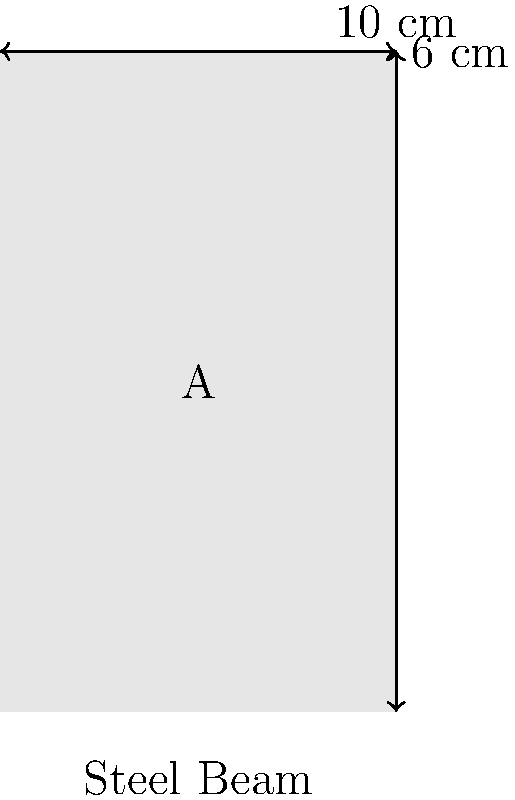A steel beam with a rectangular cross-section is shown above. The beam has a width of 6 cm and a height of 10 cm. If the yield strength of the steel is 250 MPa, calculate the maximum bending moment that the beam can safely support before yielding occurs. Assume the beam is subjected to pure bending and use the elastic section modulus method. To solve this problem, we'll follow these steps:

1) Calculate the moment of inertia (I) of the rectangular cross-section:
   $$I = \frac{bh^3}{12}$$
   where b is the width and h is the height of the cross-section.
   $$I = \frac{6 \cdot 10^3}{12} = 500 \text{ cm}^4$$

2) Calculate the distance from the neutral axis to the extreme fiber (c):
   $$c = \frac{h}{2} = \frac{10}{2} = 5 \text{ cm}$$

3) Calculate the elastic section modulus (S):
   $$S = \frac{I}{c} = \frac{500}{5} = 100 \text{ cm}^3 = 100 \times 10^{-6} \text{ m}^3$$

4) Use the flexure formula to calculate the maximum bending moment (M):
   $$M = \frac{\sigma_y \cdot I}{c} = \sigma_y \cdot S$$
   where $\sigma_y$ is the yield strength of the steel.

   $$M = 250 \times 10^6 \text{ Pa} \cdot 100 \times 10^{-6} \text{ m}^3 = 25,000 \text{ N·m}$$

Therefore, the maximum bending moment the beam can safely support is 25,000 N·m or 25 kN·m.
Answer: 25 kN·m 